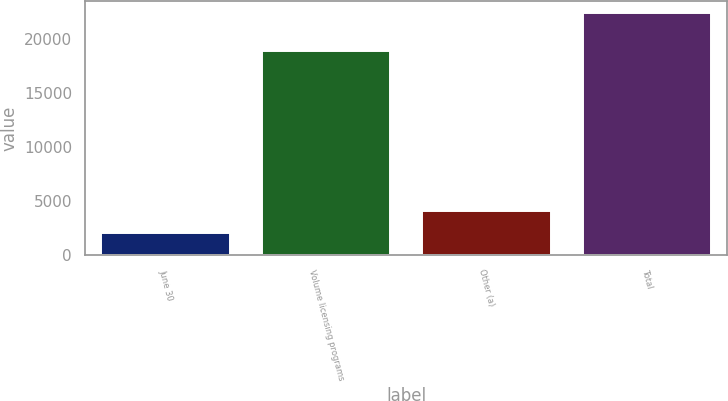Convert chart. <chart><loc_0><loc_0><loc_500><loc_500><bar_chart><fcel>June 30<fcel>Volume licensing programs<fcel>Other (a)<fcel>Total<nl><fcel>2013<fcel>18871<fcel>4051.6<fcel>22399<nl></chart> 